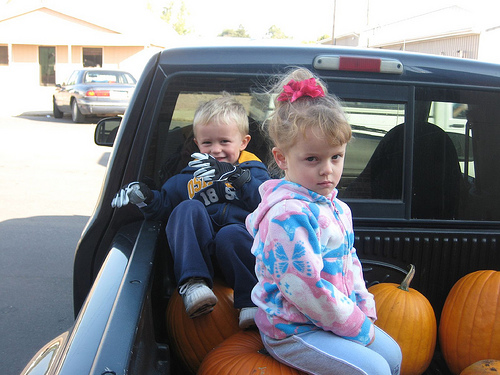<image>
Can you confirm if the boy is next to the girl? No. The boy is not positioned next to the girl. They are located in different areas of the scene. Where is the girl in relation to the truck? Is it next to the truck? No. The girl is not positioned next to the truck. They are located in different areas of the scene. Is there a girl on the boy? No. The girl is not positioned on the boy. They may be near each other, but the girl is not supported by or resting on top of the boy. 